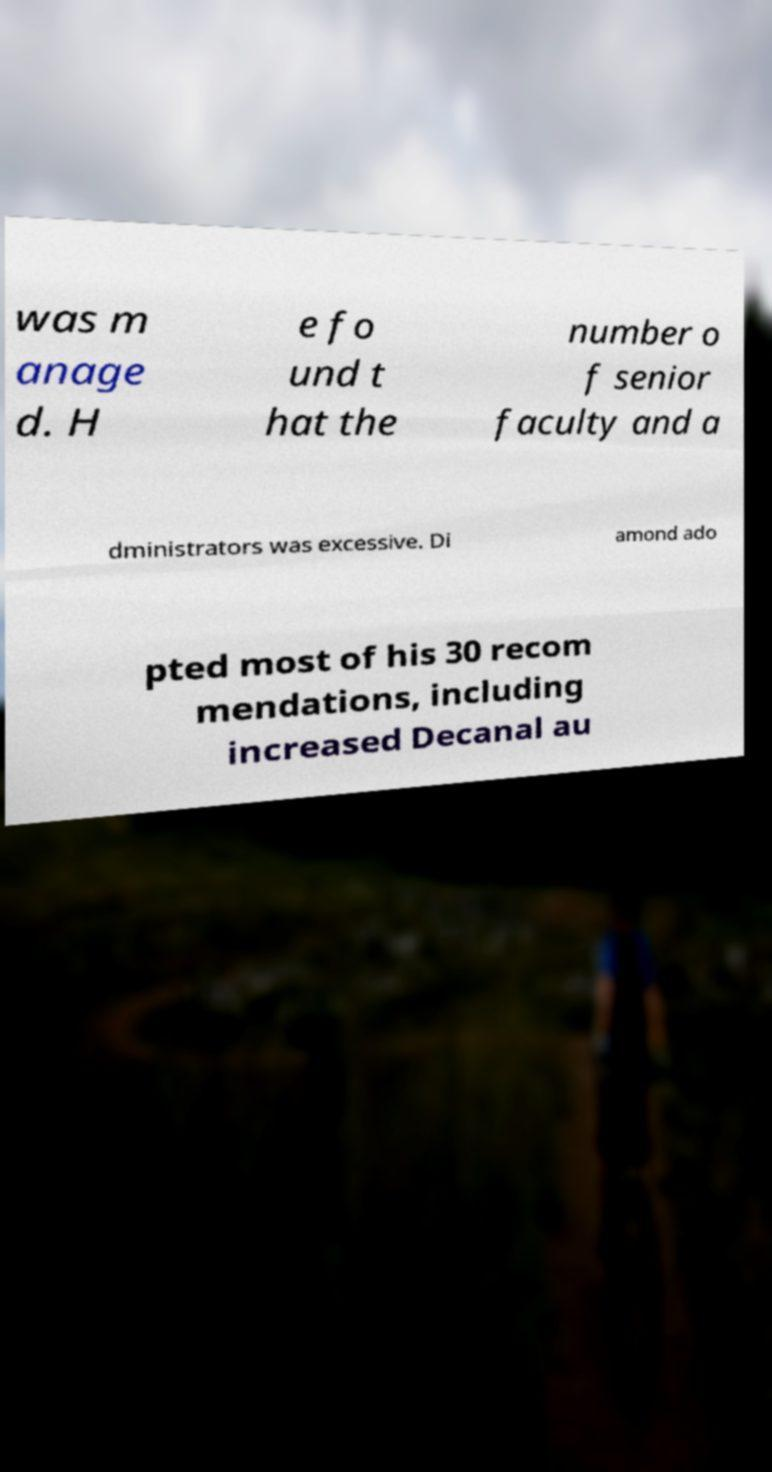There's text embedded in this image that I need extracted. Can you transcribe it verbatim? was m anage d. H e fo und t hat the number o f senior faculty and a dministrators was excessive. Di amond ado pted most of his 30 recom mendations, including increased Decanal au 